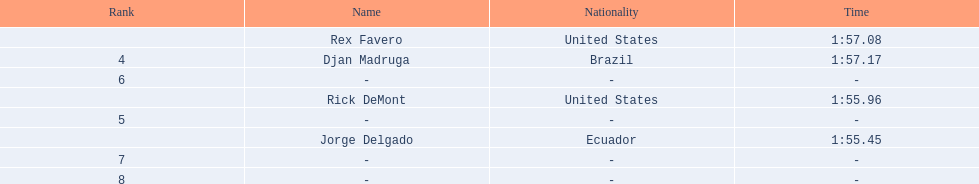What come after rex f. Djan Madruga. 